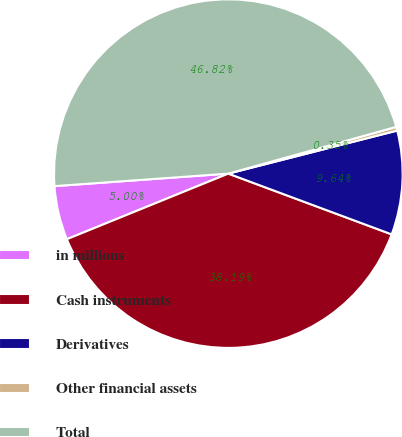<chart> <loc_0><loc_0><loc_500><loc_500><pie_chart><fcel>in millions<fcel>Cash instruments<fcel>Derivatives<fcel>Other financial assets<fcel>Total<nl><fcel>5.0%<fcel>38.19%<fcel>9.64%<fcel>0.35%<fcel>46.82%<nl></chart> 